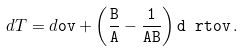Convert formula to latex. <formula><loc_0><loc_0><loc_500><loc_500>d T = d \tt o v + \left ( \frac { B } { A } - \frac { 1 } { A B } \right ) d \ r t o v \, .</formula> 